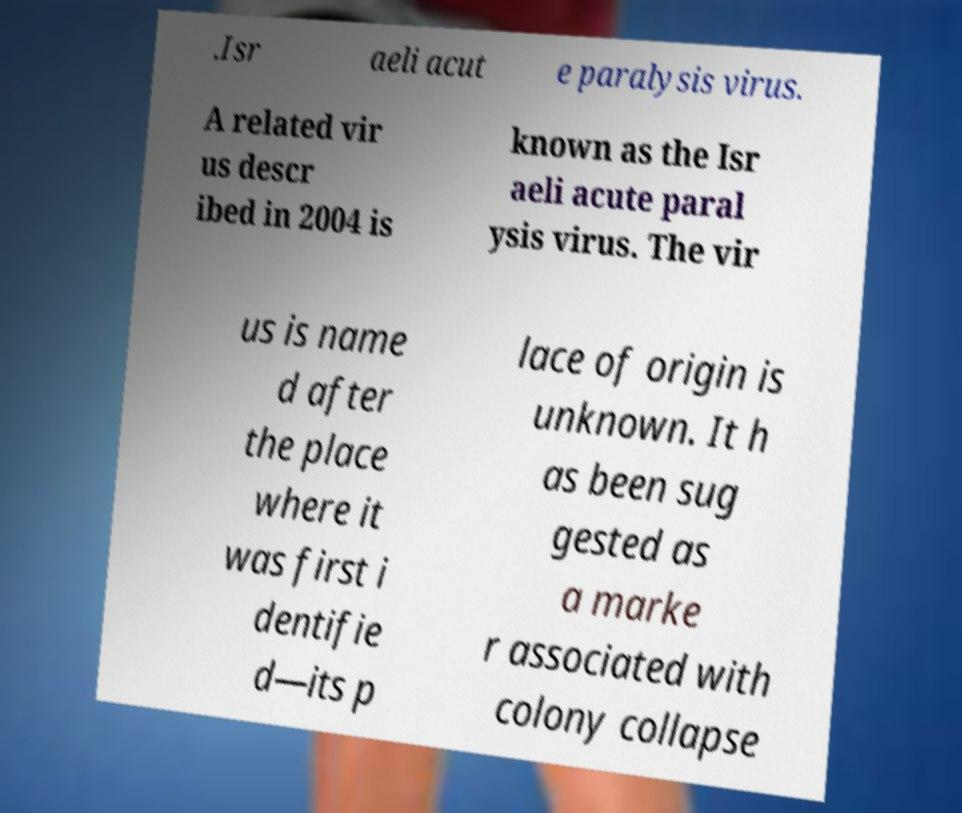Please identify and transcribe the text found in this image. .Isr aeli acut e paralysis virus. A related vir us descr ibed in 2004 is known as the Isr aeli acute paral ysis virus. The vir us is name d after the place where it was first i dentifie d—its p lace of origin is unknown. It h as been sug gested as a marke r associated with colony collapse 